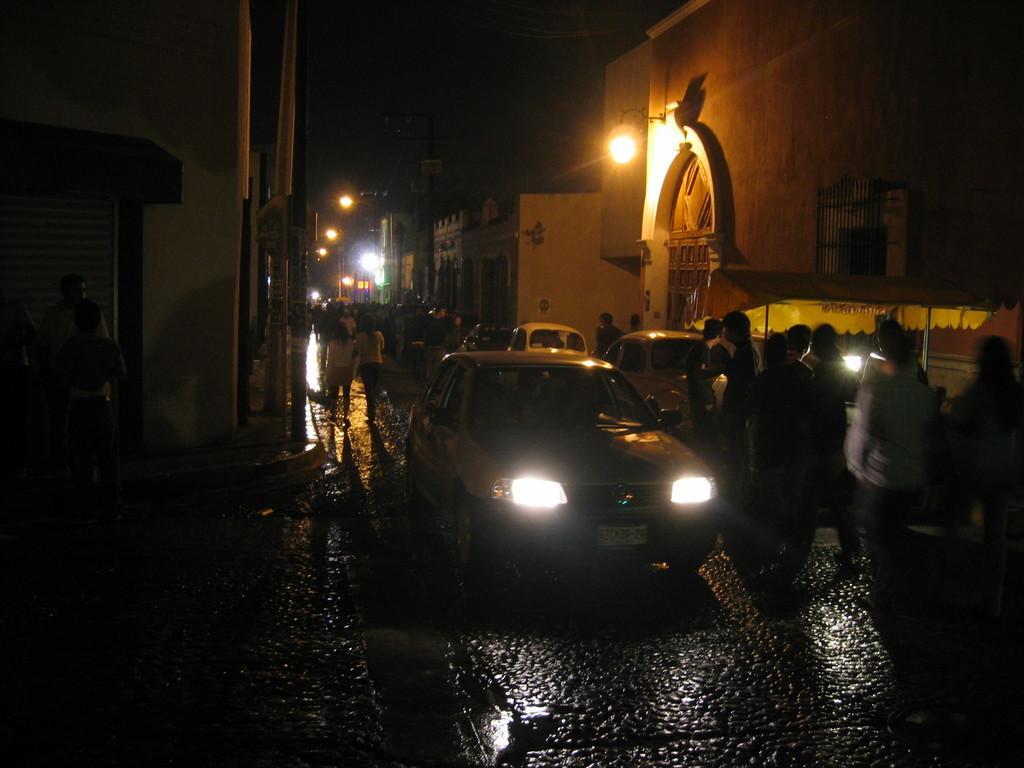Describe this image in one or two sentences. In this picture we can see a few vehicles on the path. There are some people on the path. We can see a stall on the right side. There are few buildings, lights and poles in the background. 